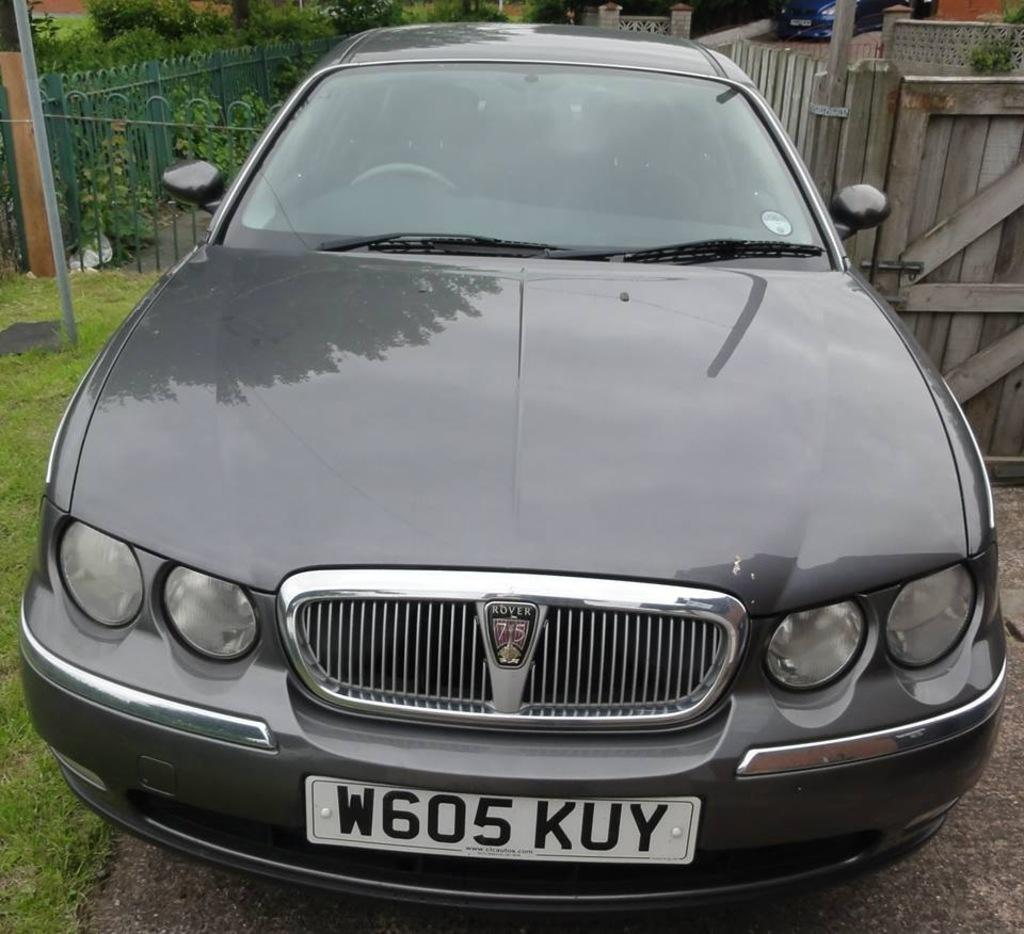What is the main subject of the image? There is a vehicle on the road in the image. What can be seen in the background of the image? In the background, there are fences, plants, a wall, poles, grass, another wall, and another vehicle. Can you describe the surroundings of the vehicle? The vehicle is surrounded by fences, plants, walls, poles, and grass in the background. Is there a volcano erupting in the background of the image? No, there is no volcano present in the image. Can you see any bones or pipes in the image? No, there are no bones or pipes visible in the image. 